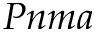<formula> <loc_0><loc_0><loc_500><loc_500>P n m a</formula> 